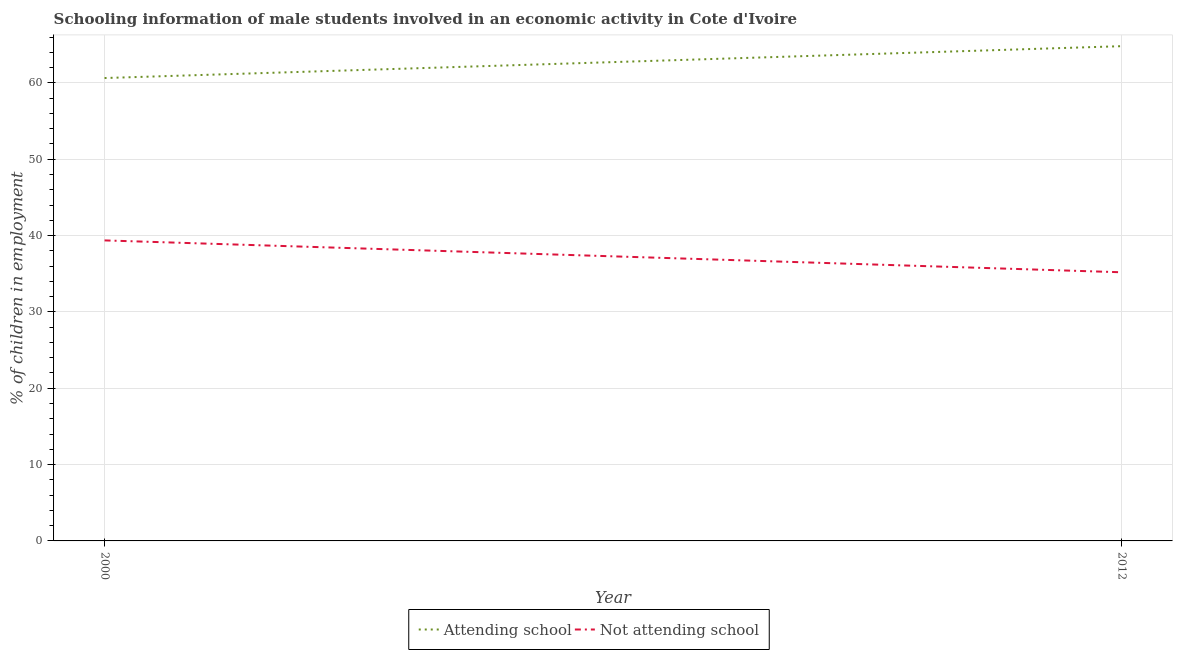Does the line corresponding to percentage of employed males who are attending school intersect with the line corresponding to percentage of employed males who are not attending school?
Provide a succinct answer. No. What is the percentage of employed males who are attending school in 2000?
Offer a very short reply. 60.64. Across all years, what is the maximum percentage of employed males who are attending school?
Provide a short and direct response. 64.81. Across all years, what is the minimum percentage of employed males who are attending school?
Ensure brevity in your answer.  60.64. In which year was the percentage of employed males who are attending school minimum?
Give a very brief answer. 2000. What is the total percentage of employed males who are not attending school in the graph?
Provide a succinct answer. 74.56. What is the difference between the percentage of employed males who are not attending school in 2000 and that in 2012?
Make the answer very short. 4.17. What is the difference between the percentage of employed males who are not attending school in 2012 and the percentage of employed males who are attending school in 2000?
Your answer should be very brief. -25.44. What is the average percentage of employed males who are not attending school per year?
Keep it short and to the point. 37.28. In the year 2012, what is the difference between the percentage of employed males who are attending school and percentage of employed males who are not attending school?
Your answer should be compact. 29.62. What is the ratio of the percentage of employed males who are not attending school in 2000 to that in 2012?
Your answer should be compact. 1.12. Is the percentage of employed males who are attending school in 2000 less than that in 2012?
Provide a succinct answer. Yes. Does the percentage of employed males who are not attending school monotonically increase over the years?
Provide a short and direct response. No. Is the percentage of employed males who are attending school strictly less than the percentage of employed males who are not attending school over the years?
Offer a very short reply. No. How many lines are there?
Provide a short and direct response. 2. How many years are there in the graph?
Your response must be concise. 2. Are the values on the major ticks of Y-axis written in scientific E-notation?
Offer a terse response. No. Does the graph contain any zero values?
Your response must be concise. No. How many legend labels are there?
Offer a very short reply. 2. What is the title of the graph?
Keep it short and to the point. Schooling information of male students involved in an economic activity in Cote d'Ivoire. Does "Short-term debt" appear as one of the legend labels in the graph?
Give a very brief answer. No. What is the label or title of the Y-axis?
Offer a terse response. % of children in employment. What is the % of children in employment in Attending school in 2000?
Make the answer very short. 60.64. What is the % of children in employment in Not attending school in 2000?
Give a very brief answer. 39.36. What is the % of children in employment in Attending school in 2012?
Provide a short and direct response. 64.81. What is the % of children in employment of Not attending school in 2012?
Provide a short and direct response. 35.19. Across all years, what is the maximum % of children in employment in Attending school?
Provide a short and direct response. 64.81. Across all years, what is the maximum % of children in employment in Not attending school?
Provide a short and direct response. 39.36. Across all years, what is the minimum % of children in employment of Attending school?
Your answer should be very brief. 60.64. Across all years, what is the minimum % of children in employment in Not attending school?
Your answer should be compact. 35.19. What is the total % of children in employment of Attending school in the graph?
Offer a very short reply. 125.44. What is the total % of children in employment in Not attending school in the graph?
Make the answer very short. 74.56. What is the difference between the % of children in employment in Attending school in 2000 and that in 2012?
Offer a very short reply. -4.17. What is the difference between the % of children in employment in Not attending school in 2000 and that in 2012?
Ensure brevity in your answer.  4.17. What is the difference between the % of children in employment of Attending school in 2000 and the % of children in employment of Not attending school in 2012?
Offer a very short reply. 25.44. What is the average % of children in employment of Attending school per year?
Keep it short and to the point. 62.72. What is the average % of children in employment of Not attending school per year?
Ensure brevity in your answer.  37.28. In the year 2000, what is the difference between the % of children in employment of Attending school and % of children in employment of Not attending school?
Provide a short and direct response. 21.27. In the year 2012, what is the difference between the % of children in employment in Attending school and % of children in employment in Not attending school?
Ensure brevity in your answer.  29.62. What is the ratio of the % of children in employment in Attending school in 2000 to that in 2012?
Your answer should be compact. 0.94. What is the ratio of the % of children in employment in Not attending school in 2000 to that in 2012?
Your answer should be compact. 1.12. What is the difference between the highest and the second highest % of children in employment in Attending school?
Provide a succinct answer. 4.17. What is the difference between the highest and the second highest % of children in employment of Not attending school?
Your answer should be very brief. 4.17. What is the difference between the highest and the lowest % of children in employment in Attending school?
Your answer should be compact. 4.17. What is the difference between the highest and the lowest % of children in employment of Not attending school?
Provide a succinct answer. 4.17. 